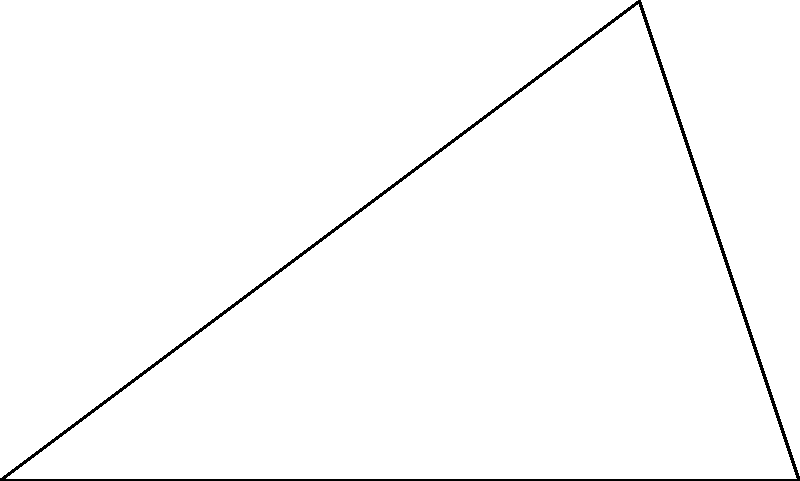In a blood spatter analysis, a forensic scientist observes a triangular pattern formed by three blood drops. The distance between two drops is 5 meters, forming the base of the triangle. Another drop is located 3 meters perpendicular to this base. What is the angle θ (in degrees) between the two 'arms' of the triangle formed by the blood drops? To solve this problem, we'll use trigonometry, specifically the arctangent function.

Step 1: Identify the right triangle in the blood spatter pattern.
The triangle formed is a right triangle with the 3-meter line as the height and half of the 5-meter line as the base of this right triangle.

Step 2: Calculate half of the base length.
Base of right triangle = 5 ÷ 2 = 2.5 meters

Step 3: Use the arctangent function to find the angle.
θ/2 = arctan(opposite / adjacent)
θ/2 = arctan(3 / 2.5)
θ/2 = arctan(1.2)

Step 4: Calculate θ/2 in radians.
θ/2 ≈ 0.8760 radians

Step 5: Convert to degrees and multiply by 2 to get the full angle.
θ ≈ 0.8760 × (180/π) × 2
θ ≈ 100.3°

Step 6: Round to the nearest degree.
θ ≈ 100°
Answer: 100° 